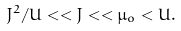<formula> <loc_0><loc_0><loc_500><loc_500>J ^ { 2 } / U < < J < < \mu _ { o } < U .</formula> 